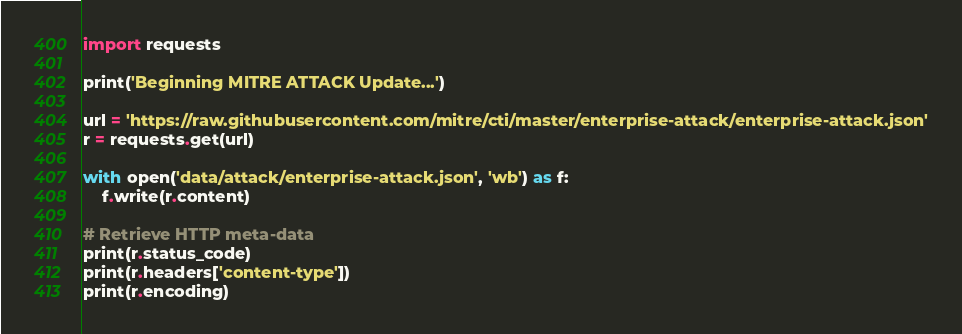Convert code to text. <code><loc_0><loc_0><loc_500><loc_500><_Python_>import requests

print('Beginning MITRE ATTACK Update...')

url = 'https://raw.githubusercontent.com/mitre/cti/master/enterprise-attack/enterprise-attack.json'
r = requests.get(url)

with open('data/attack/enterprise-attack.json', 'wb') as f:
    f.write(r.content)

# Retrieve HTTP meta-data
print(r.status_code)
print(r.headers['content-type'])
print(r.encoding)
</code> 